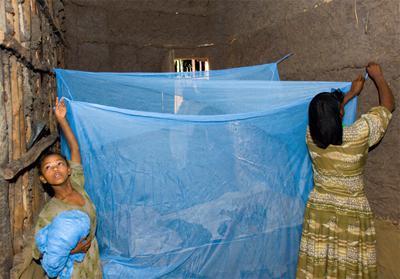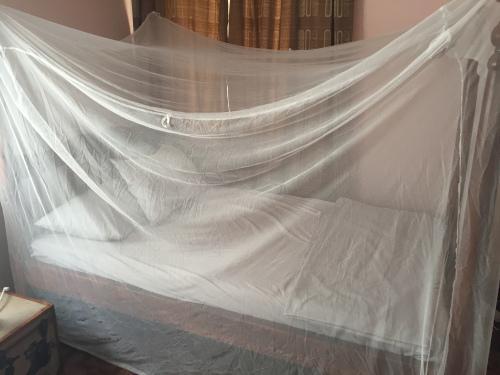The first image is the image on the left, the second image is the image on the right. For the images shown, is this caption "There are two square canopies with at least two people near it." true? Answer yes or no. Yes. The first image is the image on the left, the second image is the image on the right. Given the left and right images, does the statement "Two or more humans are visible." hold true? Answer yes or no. Yes. 